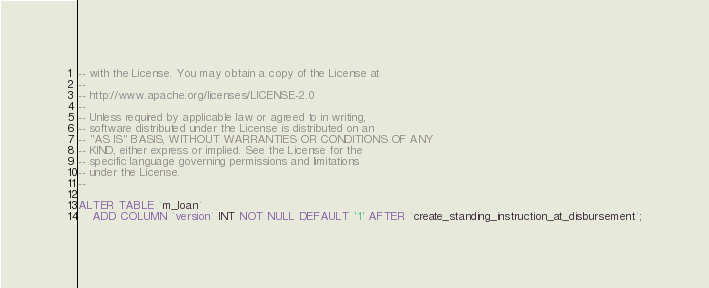<code> <loc_0><loc_0><loc_500><loc_500><_SQL_>-- with the License. You may obtain a copy of the License at
--
-- http://www.apache.org/licenses/LICENSE-2.0
--
-- Unless required by applicable law or agreed to in writing,
-- software distributed under the License is distributed on an
-- "AS IS" BASIS, WITHOUT WARRANTIES OR CONDITIONS OF ANY
-- KIND, either express or implied. See the License for the
-- specific language governing permissions and limitations
-- under the License.
--

ALTER TABLE `m_loan`
    ADD COLUMN `version` INT NOT NULL DEFAULT '1' AFTER `create_standing_instruction_at_disbursement`;
</code> 